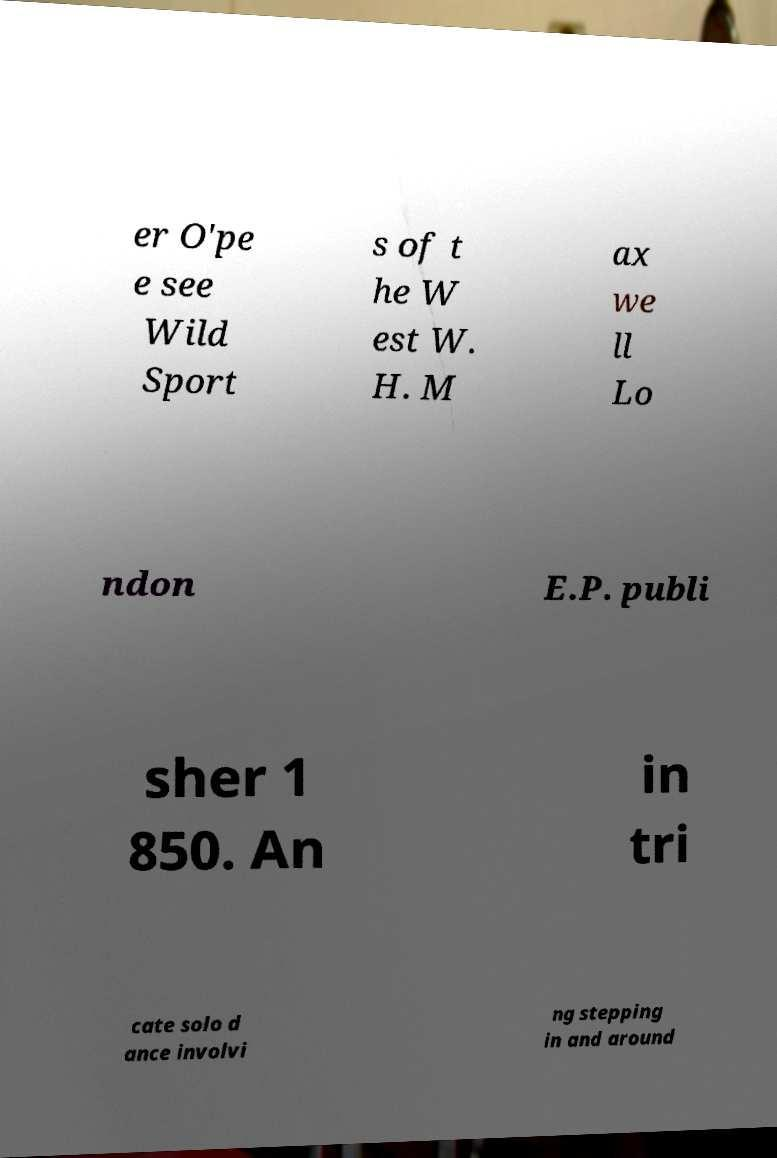Can you accurately transcribe the text from the provided image for me? er O'pe e see Wild Sport s of t he W est W. H. M ax we ll Lo ndon E.P. publi sher 1 850. An in tri cate solo d ance involvi ng stepping in and around 